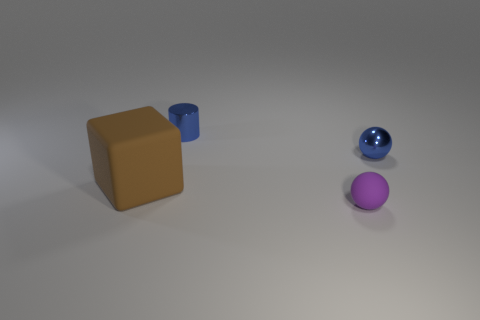Is there any other thing that is the same shape as the brown thing? Upon reviewing the image, it appears that the brown object is a cube and there are no other cubes present. There are, however, objects with different shapes: a blue cylinder and two spheres, one blue and one purple. 